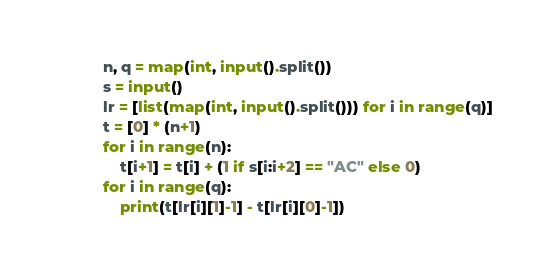<code> <loc_0><loc_0><loc_500><loc_500><_Python_>n, q = map(int, input().split())
s = input()
lr = [list(map(int, input().split())) for i in range(q)]
t = [0] * (n+1)
for i in range(n):
    t[i+1] = t[i] + (1 if s[i:i+2] == "AC" else 0)
for i in range(q):
    print(t[lr[i][1]-1] - t[lr[i][0]-1])</code> 